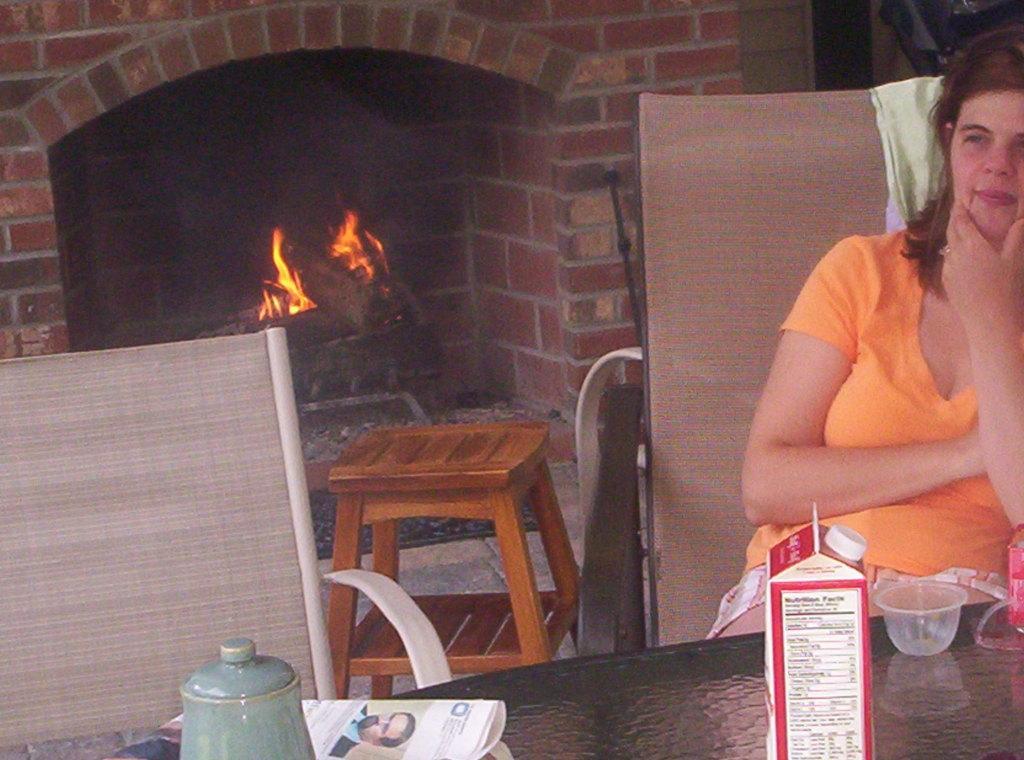In one or two sentences, can you explain what this image depicts? Here we can see a woman sitting on the chair, and in front her is the table and papers and many other objects on it, and here is the stool ,and at back here is the fire, and it is made of bricks. 